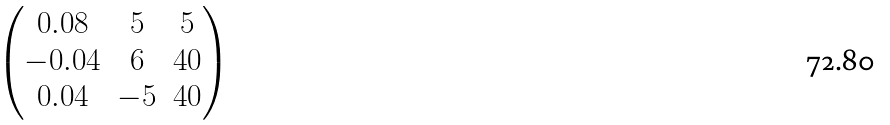Convert formula to latex. <formula><loc_0><loc_0><loc_500><loc_500>\begin{pmatrix} 0 . 0 8 & 5 & 5 \\ - 0 . 0 4 & 6 & 4 0 \\ 0 . 0 4 & - 5 & 4 0 \end{pmatrix}</formula> 